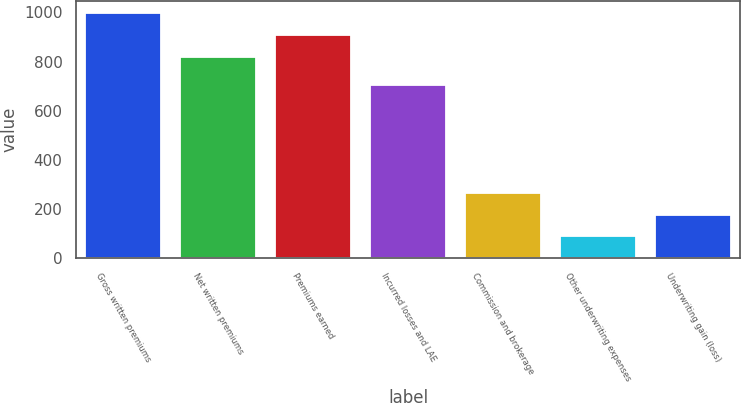<chart> <loc_0><loc_0><loc_500><loc_500><bar_chart><fcel>Gross written premiums<fcel>Net written premiums<fcel>Premiums earned<fcel>Incurred losses and LAE<fcel>Commission and brokerage<fcel>Other underwriting expenses<fcel>Underwriting gain (loss)<nl><fcel>997.72<fcel>820.5<fcel>909.11<fcel>705.9<fcel>266.72<fcel>89.5<fcel>178.11<nl></chart> 